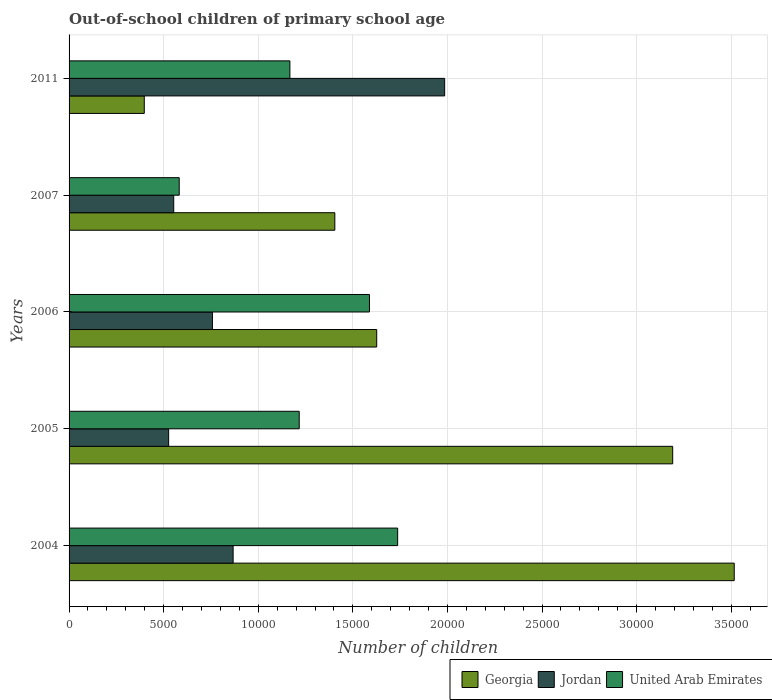How many groups of bars are there?
Your response must be concise. 5. Are the number of bars per tick equal to the number of legend labels?
Give a very brief answer. Yes. Are the number of bars on each tick of the Y-axis equal?
Offer a very short reply. Yes. How many bars are there on the 4th tick from the top?
Offer a terse response. 3. How many bars are there on the 3rd tick from the bottom?
Your answer should be very brief. 3. In how many cases, is the number of bars for a given year not equal to the number of legend labels?
Make the answer very short. 0. What is the number of out-of-school children in United Arab Emirates in 2004?
Offer a very short reply. 1.74e+04. Across all years, what is the maximum number of out-of-school children in Jordan?
Provide a short and direct response. 1.99e+04. Across all years, what is the minimum number of out-of-school children in Georgia?
Offer a very short reply. 3975. What is the total number of out-of-school children in United Arab Emirates in the graph?
Your answer should be very brief. 6.29e+04. What is the difference between the number of out-of-school children in Jordan in 2007 and that in 2011?
Your answer should be compact. -1.43e+04. What is the difference between the number of out-of-school children in Jordan in 2005 and the number of out-of-school children in United Arab Emirates in 2011?
Your response must be concise. -6409. What is the average number of out-of-school children in Jordan per year?
Provide a short and direct response. 9379. In the year 2007, what is the difference between the number of out-of-school children in Jordan and number of out-of-school children in United Arab Emirates?
Offer a terse response. -291. What is the ratio of the number of out-of-school children in United Arab Emirates in 2005 to that in 2011?
Your answer should be compact. 1.04. Is the difference between the number of out-of-school children in Jordan in 2005 and 2007 greater than the difference between the number of out-of-school children in United Arab Emirates in 2005 and 2007?
Offer a very short reply. No. What is the difference between the highest and the second highest number of out-of-school children in Jordan?
Your response must be concise. 1.12e+04. What is the difference between the highest and the lowest number of out-of-school children in Georgia?
Your answer should be compact. 3.12e+04. In how many years, is the number of out-of-school children in United Arab Emirates greater than the average number of out-of-school children in United Arab Emirates taken over all years?
Keep it short and to the point. 2. Is the sum of the number of out-of-school children in Georgia in 2005 and 2007 greater than the maximum number of out-of-school children in United Arab Emirates across all years?
Provide a succinct answer. Yes. What does the 3rd bar from the top in 2011 represents?
Ensure brevity in your answer.  Georgia. What does the 1st bar from the bottom in 2011 represents?
Make the answer very short. Georgia. How many years are there in the graph?
Your response must be concise. 5. What is the difference between two consecutive major ticks on the X-axis?
Your answer should be very brief. 5000. Are the values on the major ticks of X-axis written in scientific E-notation?
Keep it short and to the point. No. Does the graph contain grids?
Give a very brief answer. Yes. Where does the legend appear in the graph?
Provide a short and direct response. Bottom right. How many legend labels are there?
Your answer should be very brief. 3. What is the title of the graph?
Make the answer very short. Out-of-school children of primary school age. What is the label or title of the X-axis?
Provide a succinct answer. Number of children. What is the Number of children in Georgia in 2004?
Your answer should be very brief. 3.52e+04. What is the Number of children in Jordan in 2004?
Provide a succinct answer. 8671. What is the Number of children of United Arab Emirates in 2004?
Give a very brief answer. 1.74e+04. What is the Number of children of Georgia in 2005?
Provide a short and direct response. 3.19e+04. What is the Number of children in Jordan in 2005?
Your answer should be compact. 5263. What is the Number of children in United Arab Emirates in 2005?
Provide a short and direct response. 1.22e+04. What is the Number of children in Georgia in 2006?
Provide a succinct answer. 1.63e+04. What is the Number of children of Jordan in 2006?
Provide a succinct answer. 7578. What is the Number of children of United Arab Emirates in 2006?
Provide a short and direct response. 1.59e+04. What is the Number of children of Georgia in 2007?
Ensure brevity in your answer.  1.40e+04. What is the Number of children in Jordan in 2007?
Give a very brief answer. 5531. What is the Number of children of United Arab Emirates in 2007?
Give a very brief answer. 5822. What is the Number of children of Georgia in 2011?
Your answer should be very brief. 3975. What is the Number of children in Jordan in 2011?
Your response must be concise. 1.99e+04. What is the Number of children in United Arab Emirates in 2011?
Provide a short and direct response. 1.17e+04. Across all years, what is the maximum Number of children of Georgia?
Keep it short and to the point. 3.52e+04. Across all years, what is the maximum Number of children in Jordan?
Your answer should be very brief. 1.99e+04. Across all years, what is the maximum Number of children in United Arab Emirates?
Give a very brief answer. 1.74e+04. Across all years, what is the minimum Number of children of Georgia?
Your response must be concise. 3975. Across all years, what is the minimum Number of children of Jordan?
Offer a very short reply. 5263. Across all years, what is the minimum Number of children in United Arab Emirates?
Your answer should be compact. 5822. What is the total Number of children in Georgia in the graph?
Provide a succinct answer. 1.01e+05. What is the total Number of children of Jordan in the graph?
Offer a very short reply. 4.69e+04. What is the total Number of children of United Arab Emirates in the graph?
Provide a short and direct response. 6.29e+04. What is the difference between the Number of children of Georgia in 2004 and that in 2005?
Provide a succinct answer. 3253. What is the difference between the Number of children in Jordan in 2004 and that in 2005?
Your answer should be very brief. 3408. What is the difference between the Number of children in United Arab Emirates in 2004 and that in 2005?
Provide a succinct answer. 5203. What is the difference between the Number of children of Georgia in 2004 and that in 2006?
Your answer should be very brief. 1.89e+04. What is the difference between the Number of children of Jordan in 2004 and that in 2006?
Your response must be concise. 1093. What is the difference between the Number of children of United Arab Emirates in 2004 and that in 2006?
Your response must be concise. 1490. What is the difference between the Number of children of Georgia in 2004 and that in 2007?
Your response must be concise. 2.11e+04. What is the difference between the Number of children in Jordan in 2004 and that in 2007?
Give a very brief answer. 3140. What is the difference between the Number of children in United Arab Emirates in 2004 and that in 2007?
Keep it short and to the point. 1.15e+04. What is the difference between the Number of children of Georgia in 2004 and that in 2011?
Keep it short and to the point. 3.12e+04. What is the difference between the Number of children of Jordan in 2004 and that in 2011?
Make the answer very short. -1.12e+04. What is the difference between the Number of children in United Arab Emirates in 2004 and that in 2011?
Offer a very short reply. 5696. What is the difference between the Number of children in Georgia in 2005 and that in 2006?
Give a very brief answer. 1.56e+04. What is the difference between the Number of children of Jordan in 2005 and that in 2006?
Give a very brief answer. -2315. What is the difference between the Number of children in United Arab Emirates in 2005 and that in 2006?
Offer a very short reply. -3713. What is the difference between the Number of children in Georgia in 2005 and that in 2007?
Your response must be concise. 1.79e+04. What is the difference between the Number of children of Jordan in 2005 and that in 2007?
Make the answer very short. -268. What is the difference between the Number of children in United Arab Emirates in 2005 and that in 2007?
Give a very brief answer. 6343. What is the difference between the Number of children of Georgia in 2005 and that in 2011?
Offer a terse response. 2.79e+04. What is the difference between the Number of children of Jordan in 2005 and that in 2011?
Provide a short and direct response. -1.46e+04. What is the difference between the Number of children in United Arab Emirates in 2005 and that in 2011?
Keep it short and to the point. 493. What is the difference between the Number of children of Georgia in 2006 and that in 2007?
Provide a short and direct response. 2213. What is the difference between the Number of children of Jordan in 2006 and that in 2007?
Give a very brief answer. 2047. What is the difference between the Number of children in United Arab Emirates in 2006 and that in 2007?
Provide a succinct answer. 1.01e+04. What is the difference between the Number of children in Georgia in 2006 and that in 2011?
Keep it short and to the point. 1.23e+04. What is the difference between the Number of children in Jordan in 2006 and that in 2011?
Give a very brief answer. -1.23e+04. What is the difference between the Number of children in United Arab Emirates in 2006 and that in 2011?
Provide a succinct answer. 4206. What is the difference between the Number of children of Georgia in 2007 and that in 2011?
Your answer should be compact. 1.01e+04. What is the difference between the Number of children of Jordan in 2007 and that in 2011?
Offer a very short reply. -1.43e+04. What is the difference between the Number of children of United Arab Emirates in 2007 and that in 2011?
Your answer should be very brief. -5850. What is the difference between the Number of children in Georgia in 2004 and the Number of children in Jordan in 2005?
Ensure brevity in your answer.  2.99e+04. What is the difference between the Number of children of Georgia in 2004 and the Number of children of United Arab Emirates in 2005?
Keep it short and to the point. 2.30e+04. What is the difference between the Number of children of Jordan in 2004 and the Number of children of United Arab Emirates in 2005?
Give a very brief answer. -3494. What is the difference between the Number of children in Georgia in 2004 and the Number of children in Jordan in 2006?
Give a very brief answer. 2.76e+04. What is the difference between the Number of children in Georgia in 2004 and the Number of children in United Arab Emirates in 2006?
Provide a short and direct response. 1.93e+04. What is the difference between the Number of children in Jordan in 2004 and the Number of children in United Arab Emirates in 2006?
Offer a very short reply. -7207. What is the difference between the Number of children of Georgia in 2004 and the Number of children of Jordan in 2007?
Provide a short and direct response. 2.96e+04. What is the difference between the Number of children of Georgia in 2004 and the Number of children of United Arab Emirates in 2007?
Give a very brief answer. 2.93e+04. What is the difference between the Number of children in Jordan in 2004 and the Number of children in United Arab Emirates in 2007?
Offer a very short reply. 2849. What is the difference between the Number of children of Georgia in 2004 and the Number of children of Jordan in 2011?
Your answer should be very brief. 1.53e+04. What is the difference between the Number of children in Georgia in 2004 and the Number of children in United Arab Emirates in 2011?
Give a very brief answer. 2.35e+04. What is the difference between the Number of children in Jordan in 2004 and the Number of children in United Arab Emirates in 2011?
Offer a terse response. -3001. What is the difference between the Number of children in Georgia in 2005 and the Number of children in Jordan in 2006?
Offer a very short reply. 2.43e+04. What is the difference between the Number of children of Georgia in 2005 and the Number of children of United Arab Emirates in 2006?
Ensure brevity in your answer.  1.60e+04. What is the difference between the Number of children in Jordan in 2005 and the Number of children in United Arab Emirates in 2006?
Ensure brevity in your answer.  -1.06e+04. What is the difference between the Number of children of Georgia in 2005 and the Number of children of Jordan in 2007?
Your answer should be very brief. 2.64e+04. What is the difference between the Number of children in Georgia in 2005 and the Number of children in United Arab Emirates in 2007?
Provide a succinct answer. 2.61e+04. What is the difference between the Number of children in Jordan in 2005 and the Number of children in United Arab Emirates in 2007?
Make the answer very short. -559. What is the difference between the Number of children in Georgia in 2005 and the Number of children in Jordan in 2011?
Your answer should be very brief. 1.21e+04. What is the difference between the Number of children in Georgia in 2005 and the Number of children in United Arab Emirates in 2011?
Offer a very short reply. 2.02e+04. What is the difference between the Number of children in Jordan in 2005 and the Number of children in United Arab Emirates in 2011?
Make the answer very short. -6409. What is the difference between the Number of children in Georgia in 2006 and the Number of children in Jordan in 2007?
Your answer should be very brief. 1.07e+04. What is the difference between the Number of children in Georgia in 2006 and the Number of children in United Arab Emirates in 2007?
Keep it short and to the point. 1.04e+04. What is the difference between the Number of children in Jordan in 2006 and the Number of children in United Arab Emirates in 2007?
Offer a very short reply. 1756. What is the difference between the Number of children in Georgia in 2006 and the Number of children in Jordan in 2011?
Offer a very short reply. -3592. What is the difference between the Number of children in Georgia in 2006 and the Number of children in United Arab Emirates in 2011?
Your answer should be very brief. 4588. What is the difference between the Number of children in Jordan in 2006 and the Number of children in United Arab Emirates in 2011?
Give a very brief answer. -4094. What is the difference between the Number of children in Georgia in 2007 and the Number of children in Jordan in 2011?
Provide a succinct answer. -5805. What is the difference between the Number of children of Georgia in 2007 and the Number of children of United Arab Emirates in 2011?
Offer a very short reply. 2375. What is the difference between the Number of children in Jordan in 2007 and the Number of children in United Arab Emirates in 2011?
Your response must be concise. -6141. What is the average Number of children in Georgia per year?
Make the answer very short. 2.03e+04. What is the average Number of children of Jordan per year?
Offer a terse response. 9379. What is the average Number of children in United Arab Emirates per year?
Keep it short and to the point. 1.26e+04. In the year 2004, what is the difference between the Number of children in Georgia and Number of children in Jordan?
Give a very brief answer. 2.65e+04. In the year 2004, what is the difference between the Number of children in Georgia and Number of children in United Arab Emirates?
Ensure brevity in your answer.  1.78e+04. In the year 2004, what is the difference between the Number of children of Jordan and Number of children of United Arab Emirates?
Provide a short and direct response. -8697. In the year 2005, what is the difference between the Number of children in Georgia and Number of children in Jordan?
Provide a short and direct response. 2.66e+04. In the year 2005, what is the difference between the Number of children of Georgia and Number of children of United Arab Emirates?
Provide a short and direct response. 1.97e+04. In the year 2005, what is the difference between the Number of children in Jordan and Number of children in United Arab Emirates?
Make the answer very short. -6902. In the year 2006, what is the difference between the Number of children in Georgia and Number of children in Jordan?
Keep it short and to the point. 8682. In the year 2006, what is the difference between the Number of children of Georgia and Number of children of United Arab Emirates?
Make the answer very short. 382. In the year 2006, what is the difference between the Number of children in Jordan and Number of children in United Arab Emirates?
Your response must be concise. -8300. In the year 2007, what is the difference between the Number of children in Georgia and Number of children in Jordan?
Provide a succinct answer. 8516. In the year 2007, what is the difference between the Number of children in Georgia and Number of children in United Arab Emirates?
Make the answer very short. 8225. In the year 2007, what is the difference between the Number of children of Jordan and Number of children of United Arab Emirates?
Your answer should be very brief. -291. In the year 2011, what is the difference between the Number of children of Georgia and Number of children of Jordan?
Provide a succinct answer. -1.59e+04. In the year 2011, what is the difference between the Number of children of Georgia and Number of children of United Arab Emirates?
Offer a terse response. -7697. In the year 2011, what is the difference between the Number of children in Jordan and Number of children in United Arab Emirates?
Your answer should be compact. 8180. What is the ratio of the Number of children in Georgia in 2004 to that in 2005?
Your answer should be compact. 1.1. What is the ratio of the Number of children of Jordan in 2004 to that in 2005?
Your answer should be very brief. 1.65. What is the ratio of the Number of children in United Arab Emirates in 2004 to that in 2005?
Offer a very short reply. 1.43. What is the ratio of the Number of children in Georgia in 2004 to that in 2006?
Give a very brief answer. 2.16. What is the ratio of the Number of children of Jordan in 2004 to that in 2006?
Make the answer very short. 1.14. What is the ratio of the Number of children of United Arab Emirates in 2004 to that in 2006?
Give a very brief answer. 1.09. What is the ratio of the Number of children of Georgia in 2004 to that in 2007?
Offer a very short reply. 2.5. What is the ratio of the Number of children in Jordan in 2004 to that in 2007?
Offer a terse response. 1.57. What is the ratio of the Number of children in United Arab Emirates in 2004 to that in 2007?
Provide a succinct answer. 2.98. What is the ratio of the Number of children of Georgia in 2004 to that in 2011?
Your response must be concise. 8.84. What is the ratio of the Number of children in Jordan in 2004 to that in 2011?
Give a very brief answer. 0.44. What is the ratio of the Number of children of United Arab Emirates in 2004 to that in 2011?
Provide a short and direct response. 1.49. What is the ratio of the Number of children in Georgia in 2005 to that in 2006?
Give a very brief answer. 1.96. What is the ratio of the Number of children in Jordan in 2005 to that in 2006?
Offer a terse response. 0.69. What is the ratio of the Number of children in United Arab Emirates in 2005 to that in 2006?
Offer a very short reply. 0.77. What is the ratio of the Number of children of Georgia in 2005 to that in 2007?
Keep it short and to the point. 2.27. What is the ratio of the Number of children of Jordan in 2005 to that in 2007?
Keep it short and to the point. 0.95. What is the ratio of the Number of children of United Arab Emirates in 2005 to that in 2007?
Your answer should be very brief. 2.09. What is the ratio of the Number of children of Georgia in 2005 to that in 2011?
Provide a short and direct response. 8.03. What is the ratio of the Number of children in Jordan in 2005 to that in 2011?
Your answer should be very brief. 0.27. What is the ratio of the Number of children in United Arab Emirates in 2005 to that in 2011?
Your answer should be very brief. 1.04. What is the ratio of the Number of children of Georgia in 2006 to that in 2007?
Offer a very short reply. 1.16. What is the ratio of the Number of children in Jordan in 2006 to that in 2007?
Your answer should be compact. 1.37. What is the ratio of the Number of children in United Arab Emirates in 2006 to that in 2007?
Your response must be concise. 2.73. What is the ratio of the Number of children in Georgia in 2006 to that in 2011?
Your response must be concise. 4.09. What is the ratio of the Number of children of Jordan in 2006 to that in 2011?
Your response must be concise. 0.38. What is the ratio of the Number of children of United Arab Emirates in 2006 to that in 2011?
Give a very brief answer. 1.36. What is the ratio of the Number of children in Georgia in 2007 to that in 2011?
Your answer should be compact. 3.53. What is the ratio of the Number of children in Jordan in 2007 to that in 2011?
Ensure brevity in your answer.  0.28. What is the ratio of the Number of children in United Arab Emirates in 2007 to that in 2011?
Make the answer very short. 0.5. What is the difference between the highest and the second highest Number of children of Georgia?
Give a very brief answer. 3253. What is the difference between the highest and the second highest Number of children of Jordan?
Your response must be concise. 1.12e+04. What is the difference between the highest and the second highest Number of children in United Arab Emirates?
Make the answer very short. 1490. What is the difference between the highest and the lowest Number of children of Georgia?
Ensure brevity in your answer.  3.12e+04. What is the difference between the highest and the lowest Number of children in Jordan?
Offer a terse response. 1.46e+04. What is the difference between the highest and the lowest Number of children of United Arab Emirates?
Offer a terse response. 1.15e+04. 